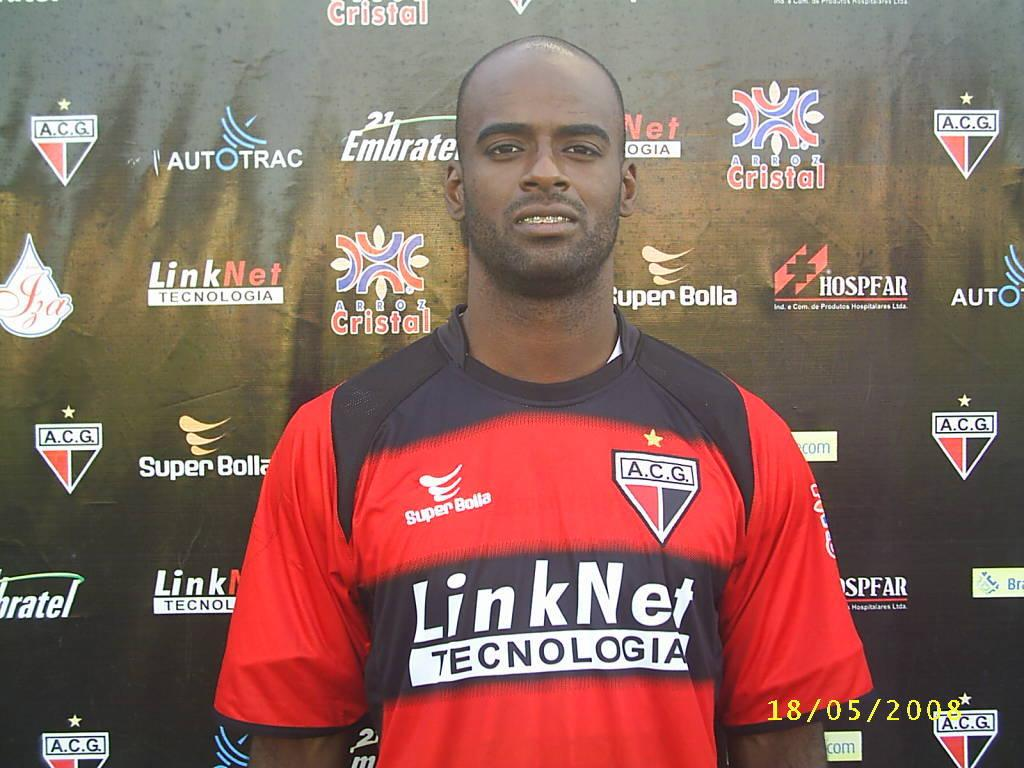<image>
Describe the image concisely. A footballer poses for the camera wearing a top sponsored by Linknet. 